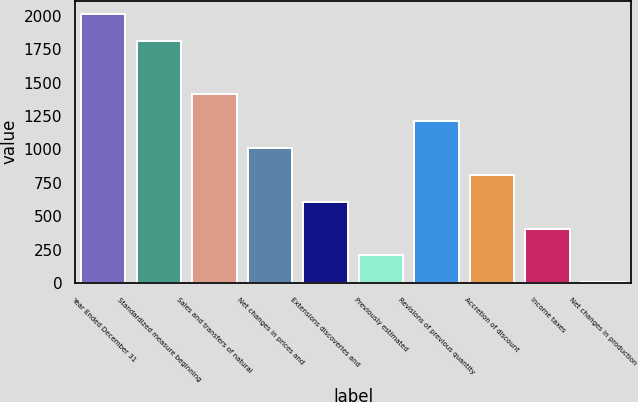Convert chart. <chart><loc_0><loc_0><loc_500><loc_500><bar_chart><fcel>Year Ended December 31<fcel>Standardized measure beginning<fcel>Sales and transfers of natural<fcel>Net changes in prices and<fcel>Extensions discoveries and<fcel>Previously estimated<fcel>Revisions of previous quantity<fcel>Accretion of discount<fcel>Income taxes<fcel>Net changes in production<nl><fcel>2013<fcel>1812.4<fcel>1411.2<fcel>1010<fcel>608.8<fcel>207.6<fcel>1210.6<fcel>809.4<fcel>408.2<fcel>7<nl></chart> 